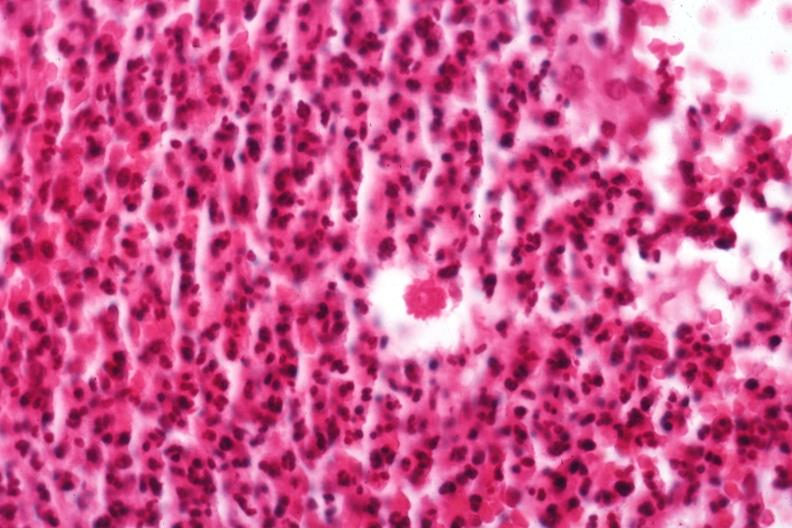s band constriction in skin above ankle of infant present?
Answer the question using a single word or phrase. No 